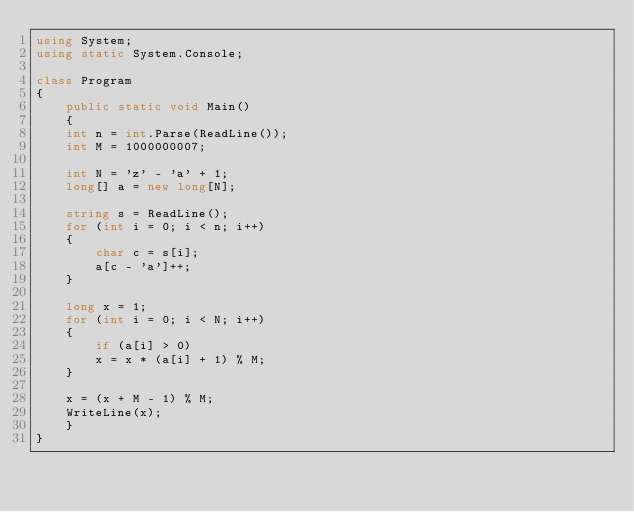Convert code to text. <code><loc_0><loc_0><loc_500><loc_500><_C#_>using System;
using static System.Console;

class Program
{
    public static void Main()
    {
	int n = int.Parse(ReadLine());
	int M = 1000000007;

	int N = 'z' - 'a' + 1;
	long[] a = new long[N];

	string s = ReadLine();
	for (int i = 0; i < n; i++)
	{
	    char c = s[i];
	    a[c - 'a']++;
	}

	long x = 1;
	for (int i = 0; i < N; i++)
	{
	    if (a[i] > 0)
		x = x * (a[i] + 1) % M;
	}

	x = (x + M - 1) % M;
	WriteLine(x);
    }
}
</code> 